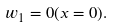Convert formula to latex. <formula><loc_0><loc_0><loc_500><loc_500>w _ { 1 } = 0 ( x = 0 ) .</formula> 